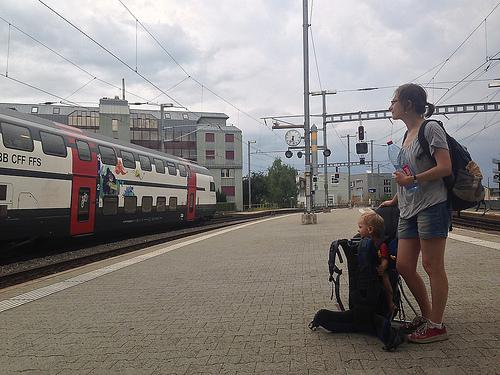Question: how would the weather be described?
Choices:
A. Overcast / cloudy.
B. Rainy.
C. Windy.
D. Gloomy.
Answer with the letter. Answer: A Question: what mode of transportation is depicted?
Choices:
A. Van.
B. Truck.
C. Train.
D. Car.
Answer with the letter. Answer: C Question: what color are the train doors?
Choices:
A. Black.
B. Red.
C. Grey.
D. Blue.
Answer with the letter. Answer: B Question: how many people are in the photo?
Choices:
A. Three.
B. Four.
C. None.
D. Two.
Answer with the letter. Answer: D Question: how many windows are visible on the train?
Choices:
A. Twenty.
B. Sixteen.
C. Ten.
D. Fifteen.
Answer with the letter. Answer: B 